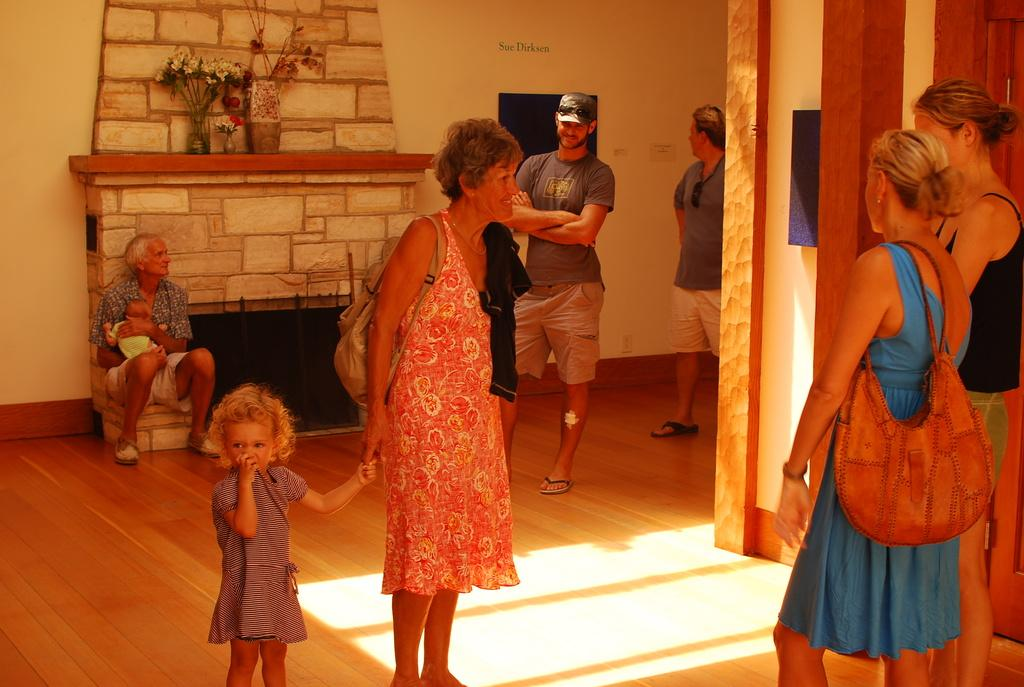How many women are present in the image? There are two women standing on the right side of the image. What is the relationship between the woman and the girl in the middle of the image? A woman is holding the hand of a girl in the middle of the image. Can you describe the man in the image? There is a man standing in the image, and he is wearing a t-shirt and shorts. What type of beef is being served on the man's finger in the image? There is no beef or any food present in the image, and the man's fingers are not visible. 